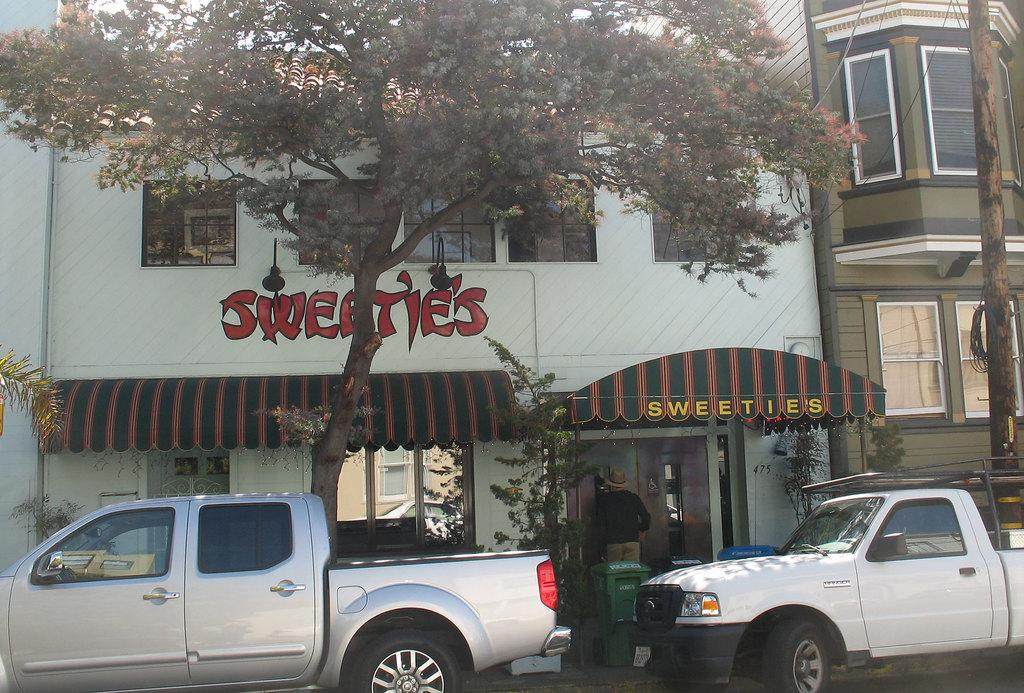What can be seen in front of the buildings in the image? There are vehicles in front of the buildings. Can you describe the person near a door in the image? One person is standing near a door. What type of natural elements are visible in the image? There are trees visible around the area. Where is the kettle located in the image? There is no kettle present in the image. What type of shoes can be seen on the person standing near the door? The image does not show the person's shoes, so it cannot be determined from the image. 